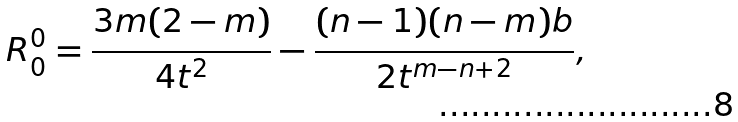Convert formula to latex. <formula><loc_0><loc_0><loc_500><loc_500>R _ { 0 } ^ { 0 } = \frac { 3 m ( 2 - m ) } { 4 t ^ { 2 } } - \frac { ( n - 1 ) ( n - m ) b } { 2 t ^ { m - n + 2 } } ,</formula> 